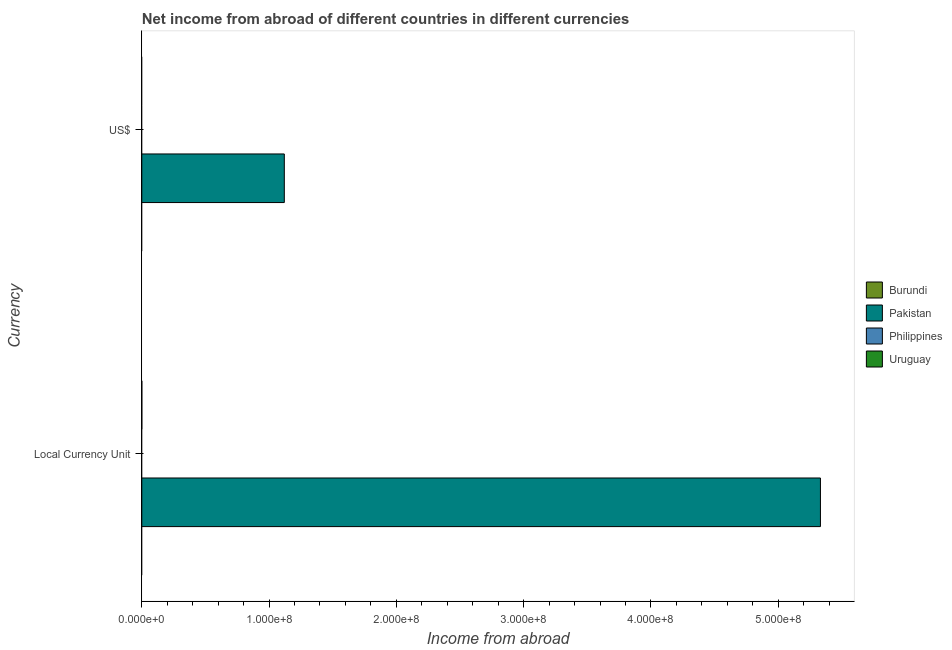How many different coloured bars are there?
Ensure brevity in your answer.  1. Are the number of bars per tick equal to the number of legend labels?
Ensure brevity in your answer.  No. How many bars are there on the 1st tick from the bottom?
Provide a succinct answer. 1. What is the label of the 2nd group of bars from the top?
Your response must be concise. Local Currency Unit. What is the income from abroad in us$ in Philippines?
Provide a short and direct response. 0. Across all countries, what is the maximum income from abroad in us$?
Make the answer very short. 1.12e+08. Across all countries, what is the minimum income from abroad in constant 2005 us$?
Your response must be concise. 0. What is the total income from abroad in constant 2005 us$ in the graph?
Your response must be concise. 5.33e+08. What is the difference between the income from abroad in us$ in Pakistan and the income from abroad in constant 2005 us$ in Philippines?
Ensure brevity in your answer.  1.12e+08. What is the average income from abroad in us$ per country?
Offer a very short reply. 2.80e+07. What is the difference between the income from abroad in us$ and income from abroad in constant 2005 us$ in Pakistan?
Make the answer very short. -4.21e+08. In how many countries, is the income from abroad in constant 2005 us$ greater than 220000000 units?
Ensure brevity in your answer.  1. How many bars are there?
Provide a short and direct response. 2. Does the graph contain any zero values?
Make the answer very short. Yes. How many legend labels are there?
Provide a short and direct response. 4. What is the title of the graph?
Your answer should be very brief. Net income from abroad of different countries in different currencies. What is the label or title of the X-axis?
Provide a succinct answer. Income from abroad. What is the label or title of the Y-axis?
Make the answer very short. Currency. What is the Income from abroad in Pakistan in Local Currency Unit?
Offer a very short reply. 5.33e+08. What is the Income from abroad in Burundi in US$?
Your answer should be compact. 0. What is the Income from abroad in Pakistan in US$?
Offer a very short reply. 1.12e+08. What is the Income from abroad of Uruguay in US$?
Offer a terse response. 0. Across all Currency, what is the maximum Income from abroad in Pakistan?
Give a very brief answer. 5.33e+08. Across all Currency, what is the minimum Income from abroad of Pakistan?
Keep it short and to the point. 1.12e+08. What is the total Income from abroad in Burundi in the graph?
Your answer should be very brief. 0. What is the total Income from abroad of Pakistan in the graph?
Keep it short and to the point. 6.45e+08. What is the total Income from abroad in Philippines in the graph?
Keep it short and to the point. 0. What is the total Income from abroad in Uruguay in the graph?
Your answer should be compact. 0. What is the difference between the Income from abroad in Pakistan in Local Currency Unit and that in US$?
Keep it short and to the point. 4.21e+08. What is the average Income from abroad in Pakistan per Currency?
Offer a terse response. 3.23e+08. What is the ratio of the Income from abroad of Pakistan in Local Currency Unit to that in US$?
Your response must be concise. 4.76. What is the difference between the highest and the second highest Income from abroad of Pakistan?
Keep it short and to the point. 4.21e+08. What is the difference between the highest and the lowest Income from abroad of Pakistan?
Your response must be concise. 4.21e+08. 